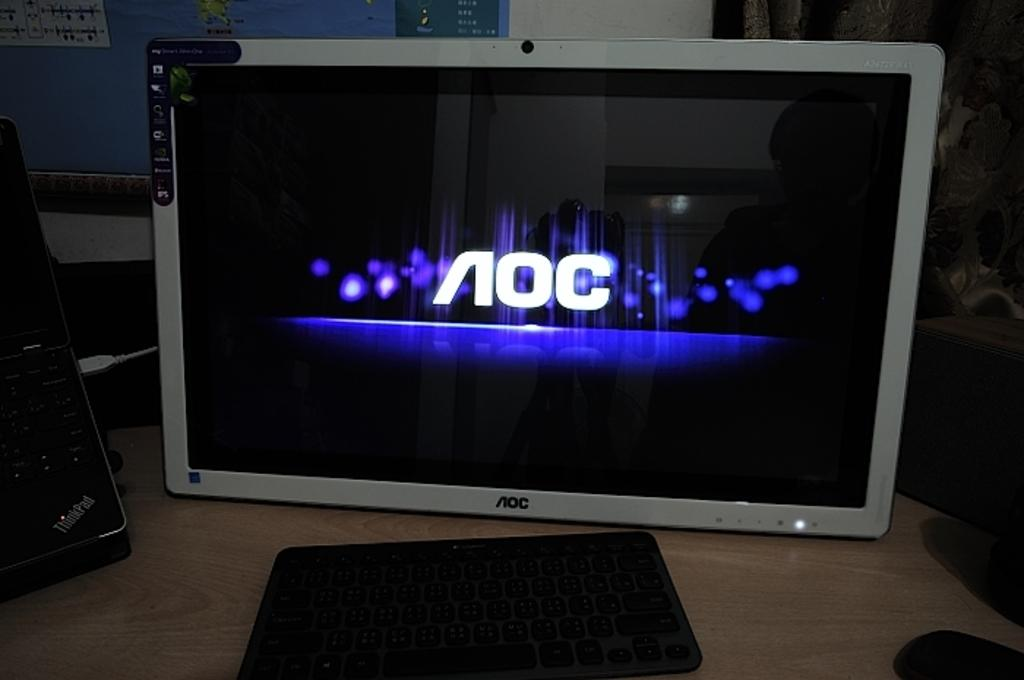<image>
Relay a brief, clear account of the picture shown. An AOC brand monitor displays the AOC logo on it. 